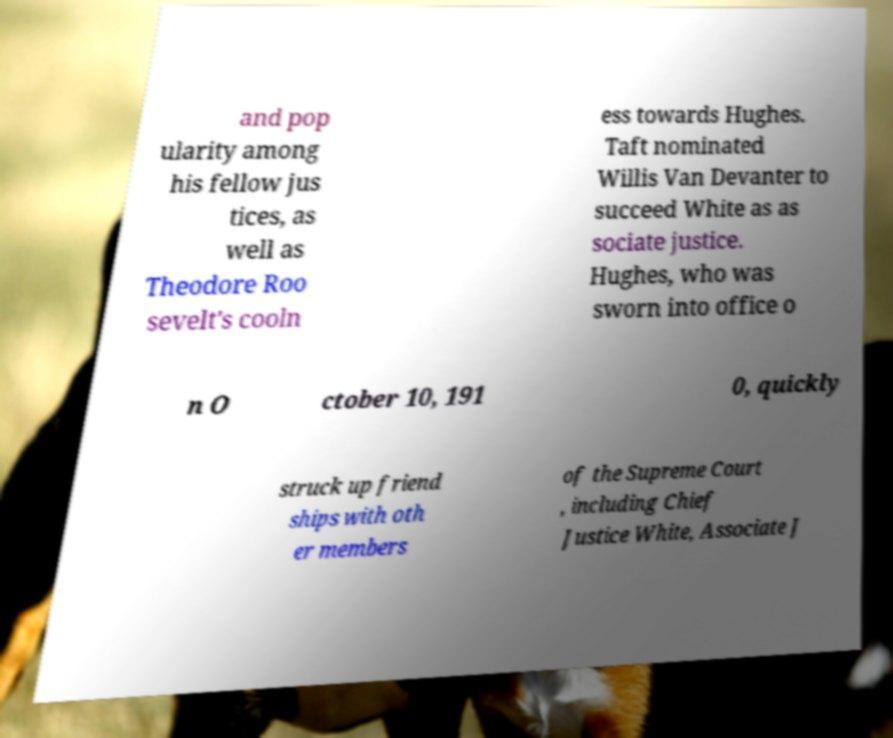Please identify and transcribe the text found in this image. and pop ularity among his fellow jus tices, as well as Theodore Roo sevelt's cooln ess towards Hughes. Taft nominated Willis Van Devanter to succeed White as as sociate justice. Hughes, who was sworn into office o n O ctober 10, 191 0, quickly struck up friend ships with oth er members of the Supreme Court , including Chief Justice White, Associate J 